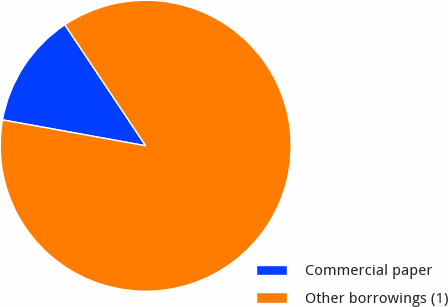Convert chart to OTSL. <chart><loc_0><loc_0><loc_500><loc_500><pie_chart><fcel>Commercial paper<fcel>Other borrowings (1)<nl><fcel>12.79%<fcel>87.21%<nl></chart> 